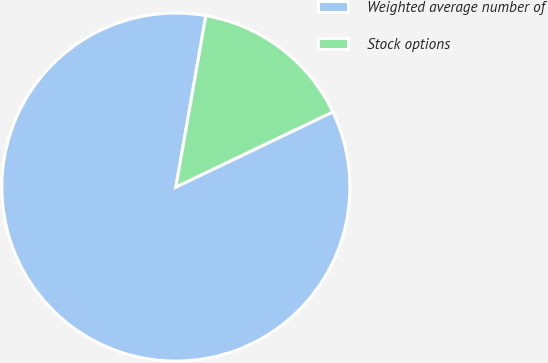Convert chart. <chart><loc_0><loc_0><loc_500><loc_500><pie_chart><fcel>Weighted average number of<fcel>Stock options<nl><fcel>84.87%<fcel>15.13%<nl></chart> 